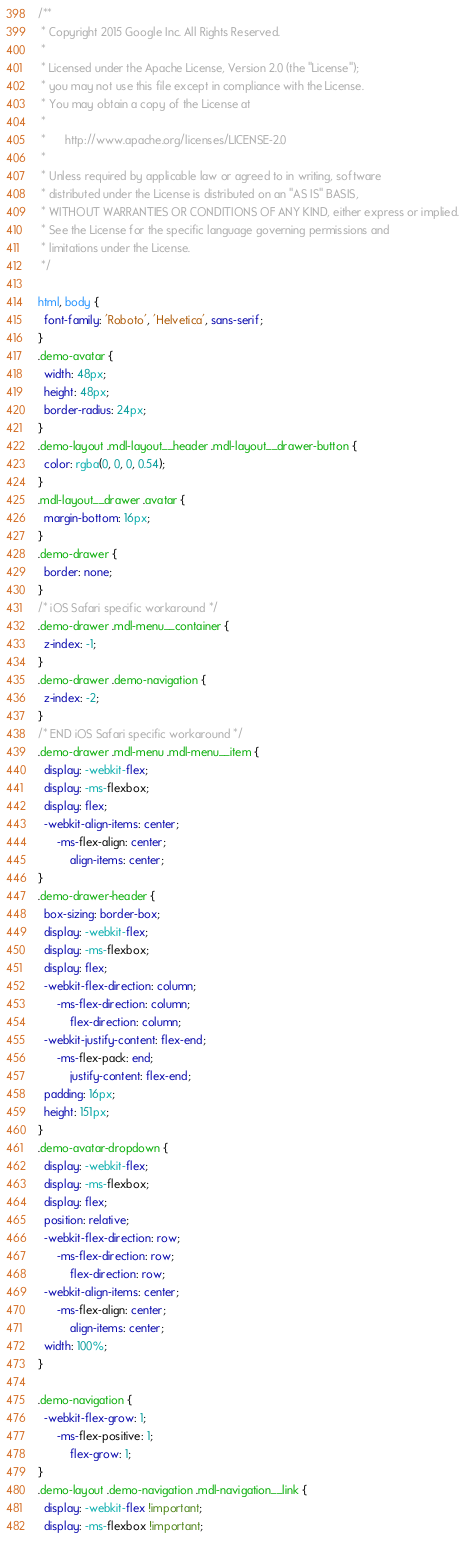Convert code to text. <code><loc_0><loc_0><loc_500><loc_500><_CSS_>/**
 * Copyright 2015 Google Inc. All Rights Reserved.
 *
 * Licensed under the Apache License, Version 2.0 (the "License");
 * you may not use this file except in compliance with the License.
 * You may obtain a copy of the License at
 *
 *      http://www.apache.org/licenses/LICENSE-2.0
 *
 * Unless required by applicable law or agreed to in writing, software
 * distributed under the License is distributed on an "AS IS" BASIS,
 * WITHOUT WARRANTIES OR CONDITIONS OF ANY KIND, either express or implied.
 * See the License for the specific language governing permissions and
 * limitations under the License.
 */

html, body {
  font-family: 'Roboto', 'Helvetica', sans-serif;
}
.demo-avatar {
  width: 48px;
  height: 48px;
  border-radius: 24px;
}
.demo-layout .mdl-layout__header .mdl-layout__drawer-button {
  color: rgba(0, 0, 0, 0.54);
}
.mdl-layout__drawer .avatar {
  margin-bottom: 16px;
}
.demo-drawer {
  border: none;
}
/* iOS Safari specific workaround */
.demo-drawer .mdl-menu__container {
  z-index: -1;
}
.demo-drawer .demo-navigation {
  z-index: -2;
}
/* END iOS Safari specific workaround */
.demo-drawer .mdl-menu .mdl-menu__item {
  display: -webkit-flex;
  display: -ms-flexbox;
  display: flex;
  -webkit-align-items: center;
      -ms-flex-align: center;
          align-items: center;
}
.demo-drawer-header {
  box-sizing: border-box;
  display: -webkit-flex;
  display: -ms-flexbox;
  display: flex;
  -webkit-flex-direction: column;
      -ms-flex-direction: column;
          flex-direction: column;
  -webkit-justify-content: flex-end;
      -ms-flex-pack: end;
          justify-content: flex-end;
  padding: 16px;
  height: 151px;
}
.demo-avatar-dropdown {
  display: -webkit-flex;
  display: -ms-flexbox;
  display: flex;
  position: relative;
  -webkit-flex-direction: row;
      -ms-flex-direction: row;
          flex-direction: row;
  -webkit-align-items: center;
      -ms-flex-align: center;
          align-items: center;
  width: 100%;
}

.demo-navigation {
  -webkit-flex-grow: 1;
      -ms-flex-positive: 1;
          flex-grow: 1;
}
.demo-layout .demo-navigation .mdl-navigation__link {
  display: -webkit-flex !important;
  display: -ms-flexbox !important;</code> 